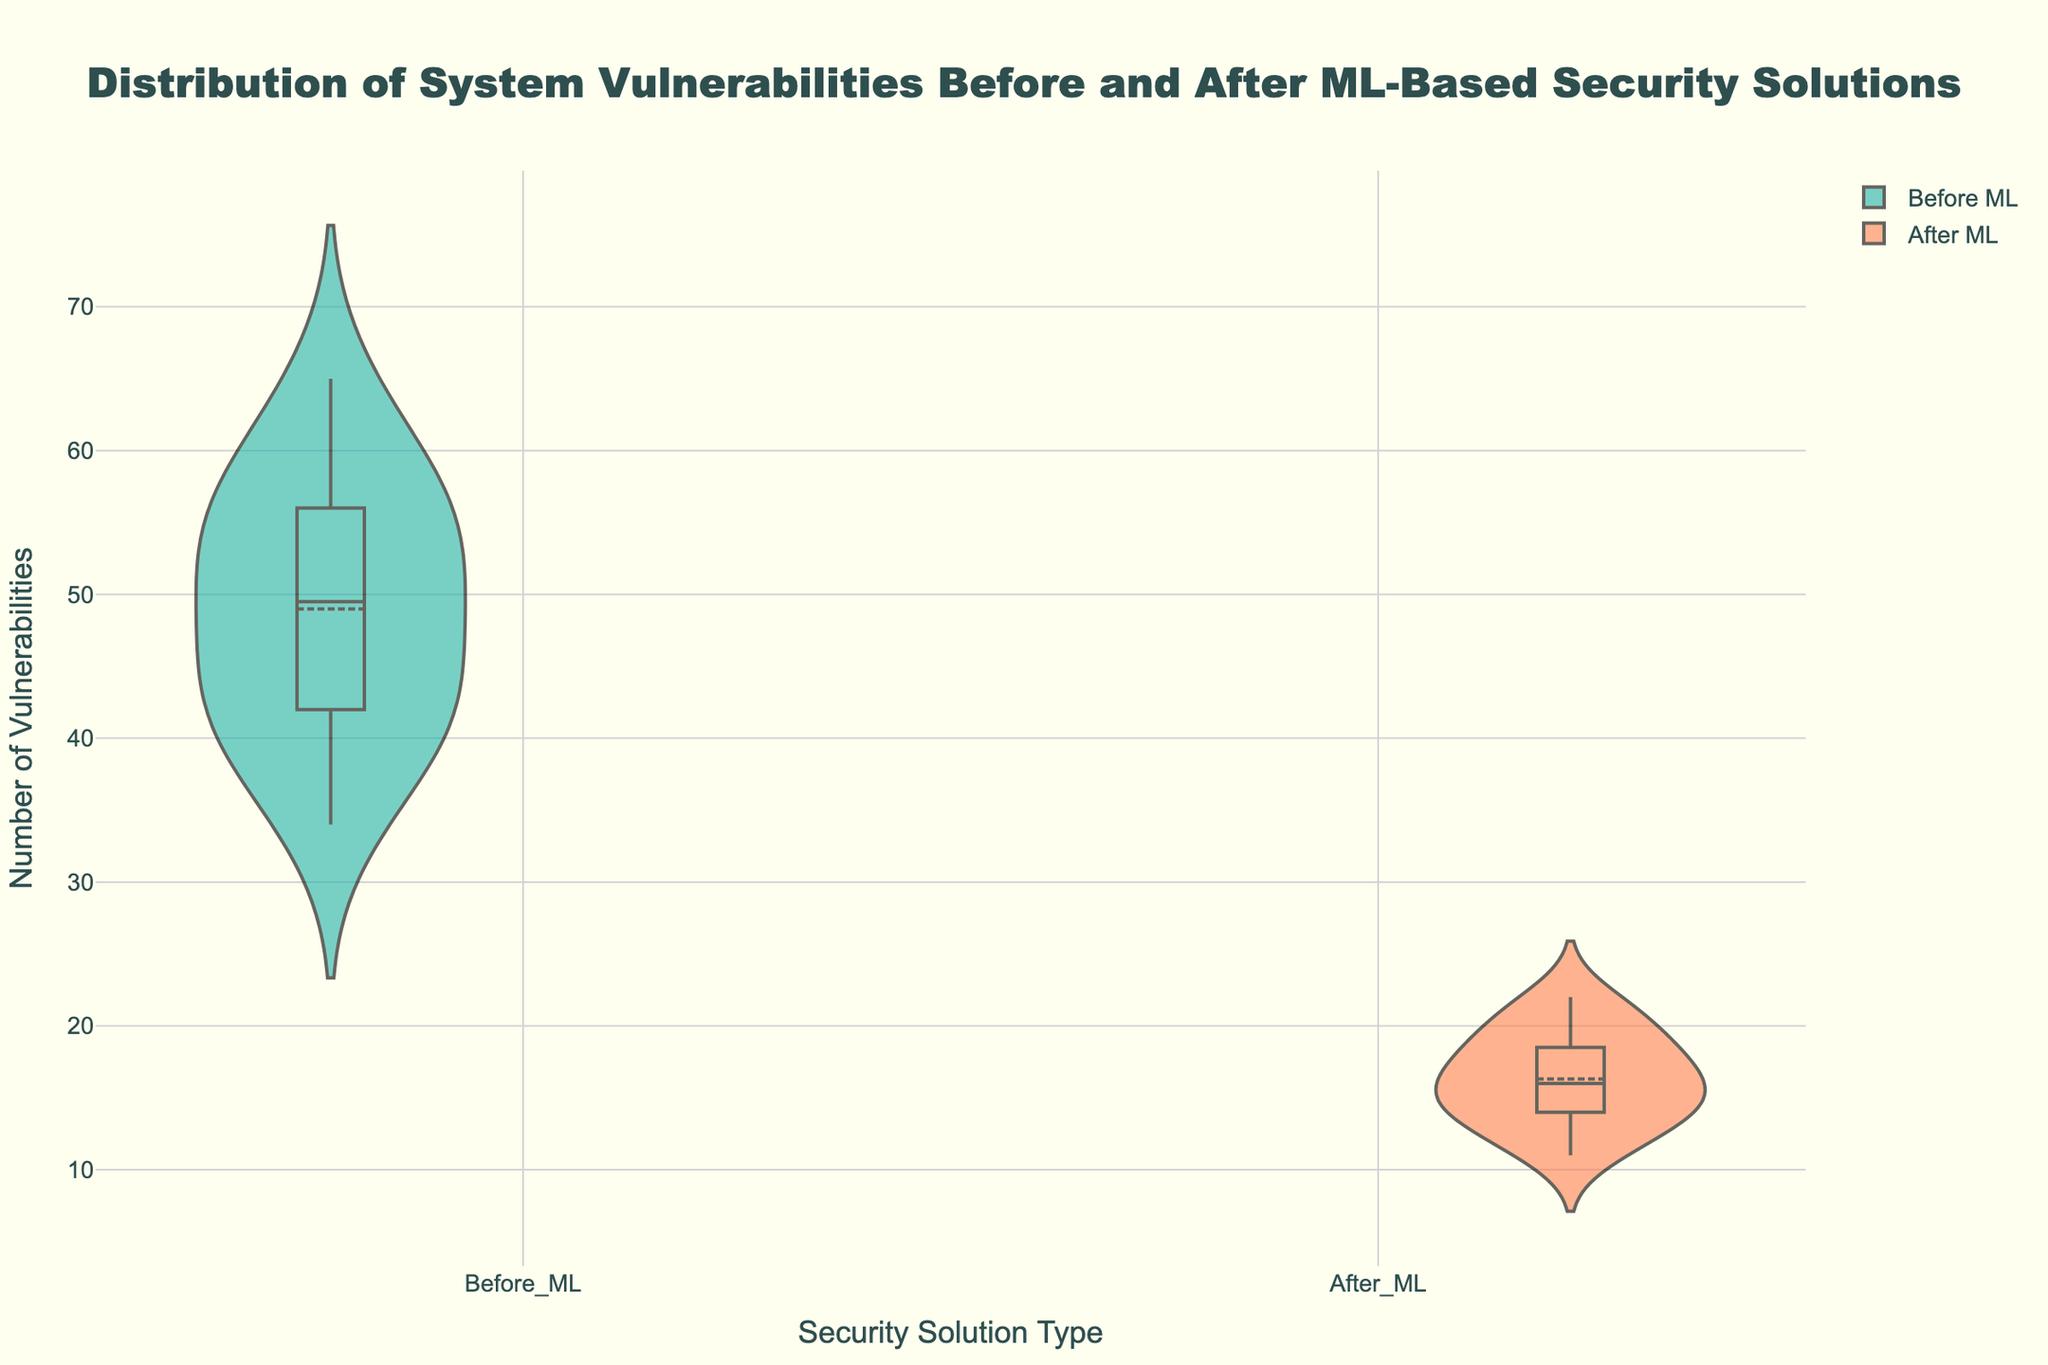What is the title of the plot? The large text at the top center of the plot describes the title.
Answer: Distribution of System Vulnerabilities Before and After ML-Based Security Solutions What are the y-axis title and axis labels? The y-axis title is indicated as text to the left of the plot, and the labels are the numerical values running along the y-axis.
Answer: Number of Vulnerabilities, Numerical values Which security solution type shows a higher number of vulnerabilities on average? Compare the central tendency (e.g., meanline) of both 'Before ML' and 'After ML' distributions.
Answer: Before ML How does the spread of vulnerabilities differ between the two scenarios (Before ML and After ML)? Assess the range and spread of the data points in each violin plot, considering the width and extent of the distribution.
Answer: 'Before ML' has a wider distribution What is the color used to represent 'After ML'? Observe the color filling the violin plot labeled 'After ML'.
Answer: Coral What is the median number of vulnerabilities for systems after the introduction of machine learning-based security solutions? Look at the central horizontal line within the 'After ML' violin plot box.
Answer: 16 How many data points are present in each security solution type? Count the individual data points represented by dots in each of the visualizations.
Answer: 16 Which scenario, 'Before ML' or 'After ML', has a lower interquartile range (IQR)? Compare the height of the box (from the lower to the upper quartile) for each security solution type.
Answer: After ML Is there an overlap in the range of vulnerabilities between 'Before ML' and 'After ML'? Check if the minimum and maximum values of one group fall within the range of the other group.
Answer: Yes What is the maximum number of vulnerabilities recorded for 'Before ML' and 'After ML'? Identify the topmost point of each violin plot.
Answer: 65 (Before ML), 22 (After ML) 